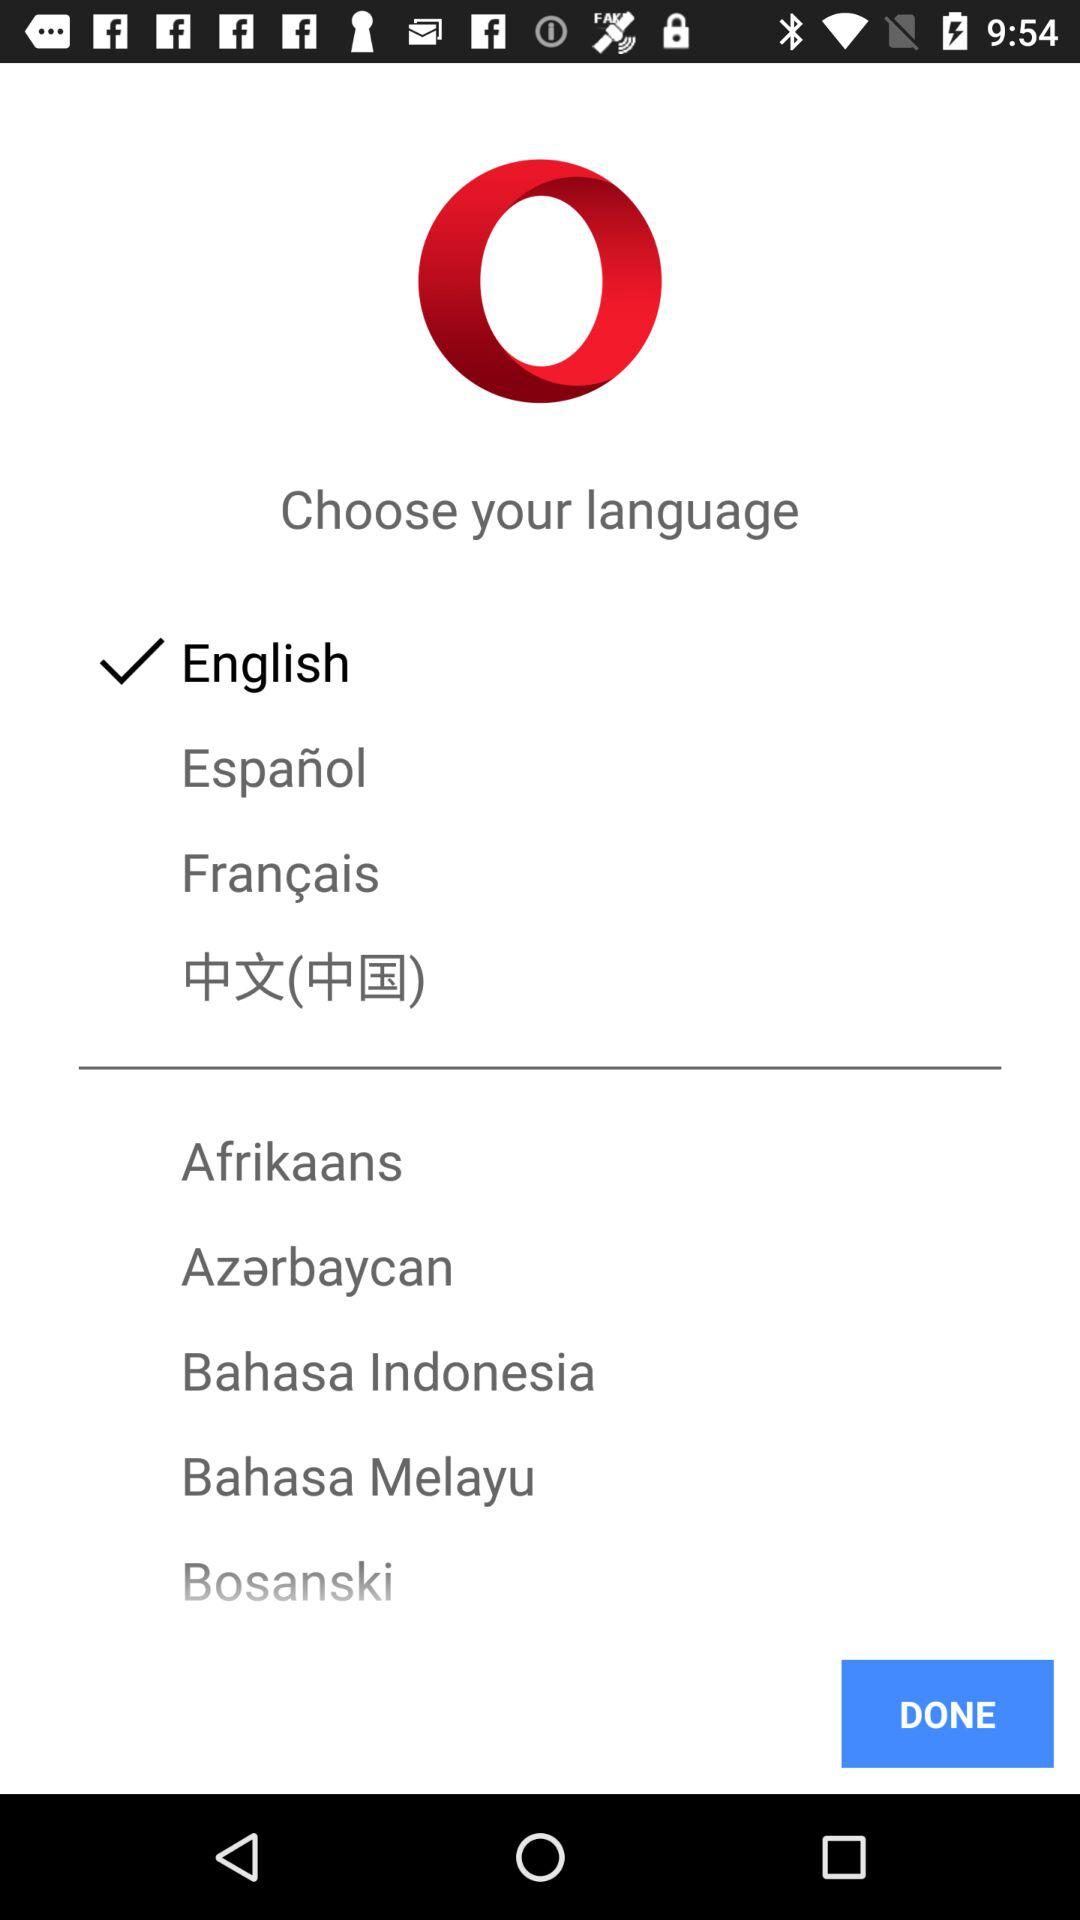What are the options available for the language?
When the provided information is insufficient, respond with <no answer>. <no answer> 